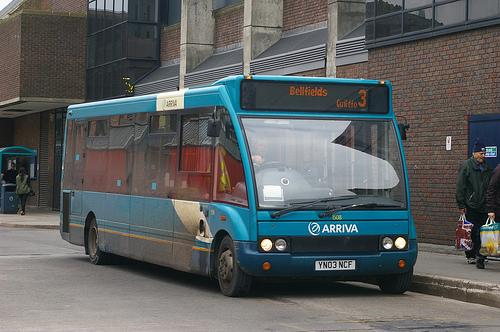Identify the object that is unusual or interesting in this image. The blue metal trashcan placed by the sidewalk, next to the blue bus, is an unusual object in this image. Describe the actions of people in the image. Two people are walking on the sidewalk carrying bags, one man has two bags, and a woman walks in the opposite direction at a distance. Provide details about the bus in the image. The blue bus has a black windshield, headlights, digital window, bus brand logo, white label, black rear view window, white strip, license plate, and a driver at the steering wheel. Mention the primary object in the picture and provide some details about it. A blue bus is parked by the sidewalk, featuring a digital window on top, black wheels on the side, and white and black license plate on the front. State any architectural details seen in this image. The bricked side of a building can be seen in the image, along with dark windows with black framing and a decal on the side. Describe any distinctive features of the people walking on the sidewalk. One man is carrying two bags, one of which looks like the Britain flag, while a lady walks in the opposite direction at a distance. What are the significant elements seen in the image? The image shows a blue bus parked next to a sidewalk, black wheels, two people walking on sidewalk, a bricked building, and a blue metal trashcan. Describe the road and pavement in the image. The image features gray pavement on the road next to the parked blue bus and the bricked building. What can you infer about the bus route and destination from the image? The destination for the bus is Bellfields, as indicated by the digital route sign on its top. Specify any objects related to driving or automobile functions in this image. There's a tire, mirror, wipers, and a light on the bus, as well as a bus driver holding the steering wheel, in this image. 